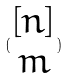Convert formula to latex. <formula><loc_0><loc_0><loc_500><loc_500>( \begin{matrix} [ n ] \\ m \end{matrix} )</formula> 